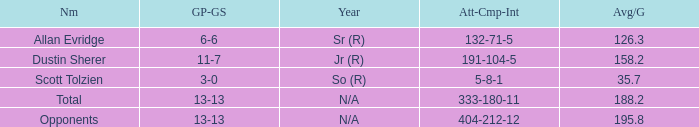Which quarterback had an Avg/G of 195.8? Opponents. 